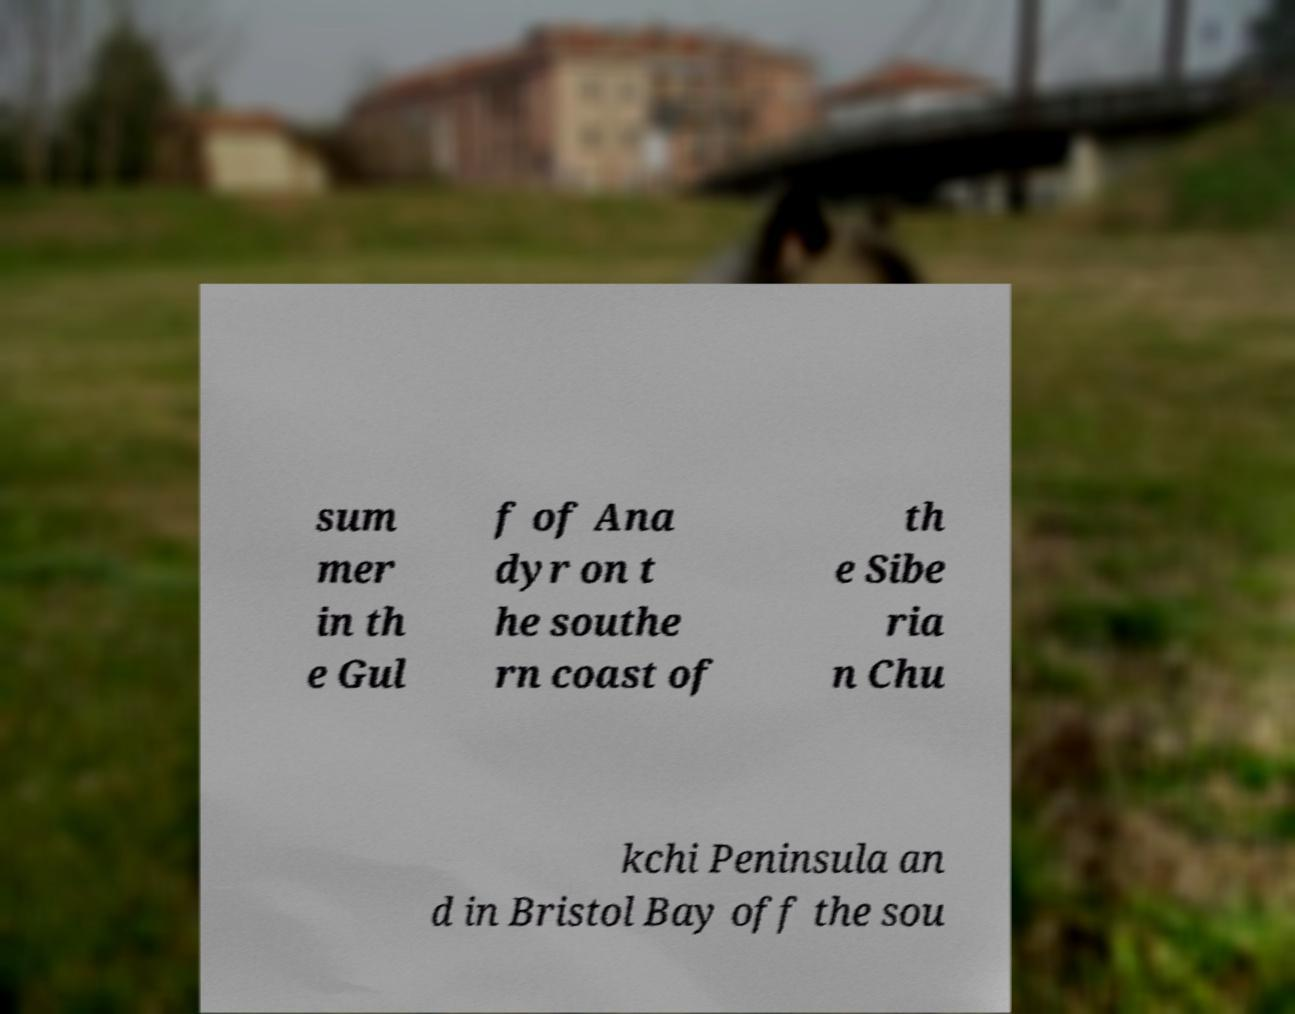Please read and relay the text visible in this image. What does it say? sum mer in th e Gul f of Ana dyr on t he southe rn coast of th e Sibe ria n Chu kchi Peninsula an d in Bristol Bay off the sou 